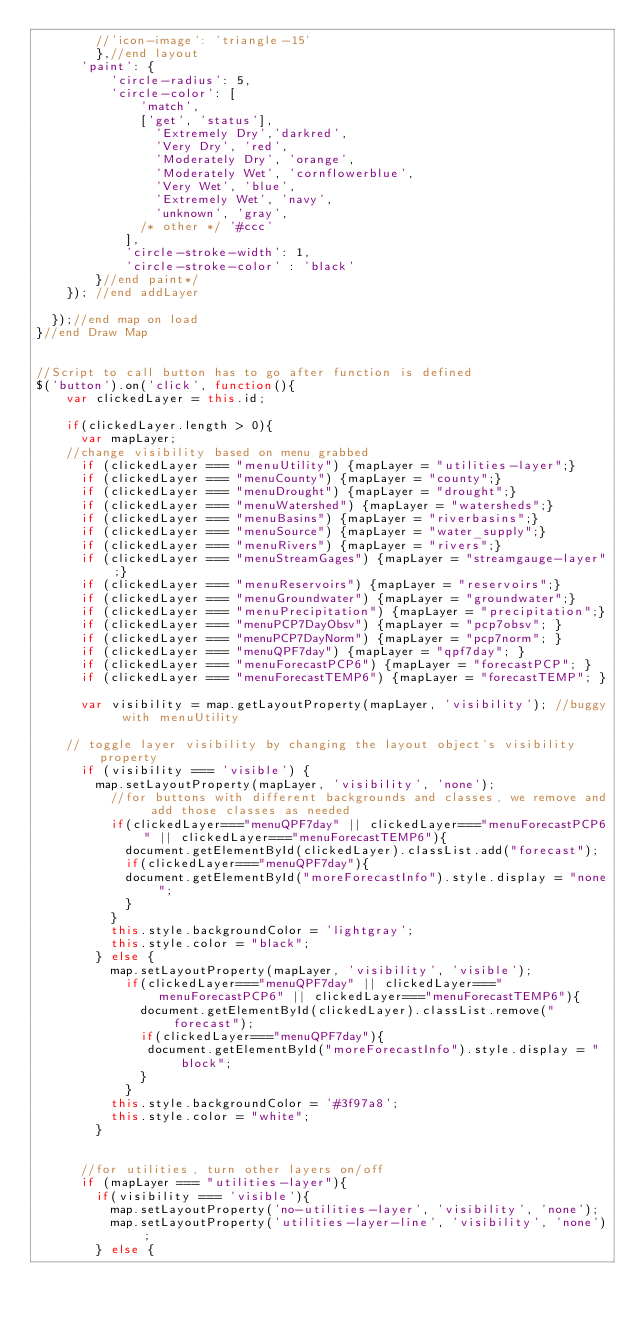<code> <loc_0><loc_0><loc_500><loc_500><_JavaScript_>        //'icon-image': 'triangle-15'
        },//end layout
      'paint': {
          'circle-radius': 5,
          'circle-color': [ 
              'match',
              ['get', 'status'],
                'Extremely Dry','darkred',
                'Very Dry', 'red',
                'Moderately Dry', 'orange',
                'Moderately Wet', 'cornflowerblue',
                'Very Wet', 'blue',
                'Extremely Wet', 'navy',
                'unknown', 'gray',
              /* other */ '#ccc'
            ],
            'circle-stroke-width': 1,
            'circle-stroke-color' : 'black'
        }//end paint*/
    }); //end addLayer

  });//end map on load
}//end Draw Map


//Script to call button has to go after function is defined
$('button').on('click', function(){ 
    var clickedLayer = this.id;

    if(clickedLayer.length > 0){
      var mapLayer;
    //change visibility based on menu grabbed
      if (clickedLayer === "menuUtility") {mapLayer = "utilities-layer";}
      if (clickedLayer === "menuCounty") {mapLayer = "county";}
      if (clickedLayer === "menuDrought") {mapLayer = "drought";}
      if (clickedLayer === "menuWatershed") {mapLayer = "watersheds";}
      if (clickedLayer === "menuBasins") {mapLayer = "riverbasins";}
      if (clickedLayer === "menuSource") {mapLayer = "water_supply";}
      if (clickedLayer === "menuRivers") {mapLayer = "rivers";}
      if (clickedLayer === "menuStreamGages") {mapLayer = "streamgauge-layer";}
      if (clickedLayer === "menuReservoirs") {mapLayer = "reservoirs";}
      if (clickedLayer === "menuGroundwater") {mapLayer = "groundwater";}
      if (clickedLayer === "menuPrecipitation") {mapLayer = "precipitation";}
      if (clickedLayer === "menuPCP7DayObsv") {mapLayer = "pcp7obsv"; }
      if (clickedLayer === "menuPCP7DayNorm") {mapLayer = "pcp7norm"; }
      if (clickedLayer === "menuQPF7day") {mapLayer = "qpf7day"; }
      if (clickedLayer === "menuForecastPCP6") {mapLayer = "forecastPCP"; }
      if (clickedLayer === "menuForecastTEMP6") {mapLayer = "forecastTEMP"; }

      var visibility = map.getLayoutProperty(mapLayer, 'visibility'); //buggy with menuUtility
      
    // toggle layer visibility by changing the layout object's visibility property
      if (visibility === 'visible') {
        map.setLayoutProperty(mapLayer, 'visibility', 'none');
          //for buttons with different backgrounds and classes, we remove and add those classes as needed
          if(clickedLayer==="menuQPF7day" || clickedLayer==="menuForecastPCP6" || clickedLayer==="menuForecastTEMP6"){ 
            document.getElementById(clickedLayer).classList.add("forecast"); 
            if(clickedLayer==="menuQPF7day"){
            document.getElementById("moreForecastInfo").style.display = "none";
            }
          }
          this.style.backgroundColor = 'lightgray';
          this.style.color = "black";
        } else {
          map.setLayoutProperty(mapLayer, 'visibility', 'visible');
            if(clickedLayer==="menuQPF7day" || clickedLayer==="menuForecastPCP6" || clickedLayer==="menuForecastTEMP6"){ 
              document.getElementById(clickedLayer).classList.remove("forecast"); 
              if(clickedLayer==="menuQPF7day"){
               document.getElementById("moreForecastInfo").style.display = "block";
              }
            }
          this.style.backgroundColor = '#3f97a8';
          this.style.color = "white";
        }


      //for utilities, turn other layers on/off
      if (mapLayer === "utilities-layer"){ 
        if(visibility === 'visible'){
          map.setLayoutProperty('no-utilities-layer', 'visibility', 'none');
          map.setLayoutProperty('utilities-layer-line', 'visibility', 'none');
        } else {</code> 